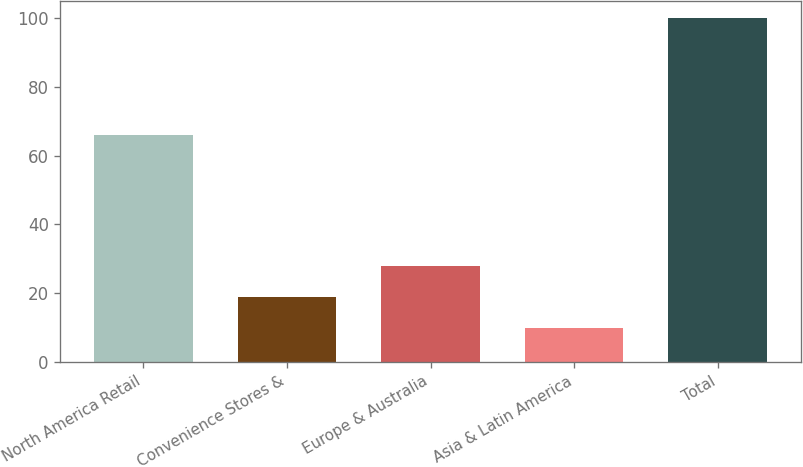<chart> <loc_0><loc_0><loc_500><loc_500><bar_chart><fcel>North America Retail<fcel>Convenience Stores &<fcel>Europe & Australia<fcel>Asia & Latin America<fcel>Total<nl><fcel>66<fcel>19<fcel>28<fcel>10<fcel>100<nl></chart> 